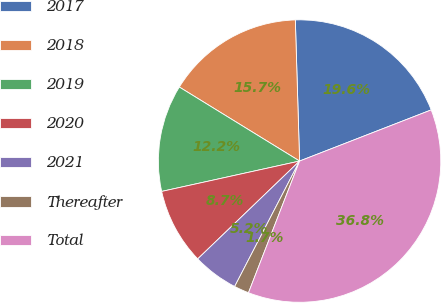<chart> <loc_0><loc_0><loc_500><loc_500><pie_chart><fcel>2017<fcel>2018<fcel>2019<fcel>2020<fcel>2021<fcel>Thereafter<fcel>Total<nl><fcel>19.58%<fcel>15.74%<fcel>12.23%<fcel>8.73%<fcel>5.22%<fcel>1.71%<fcel>36.79%<nl></chart> 